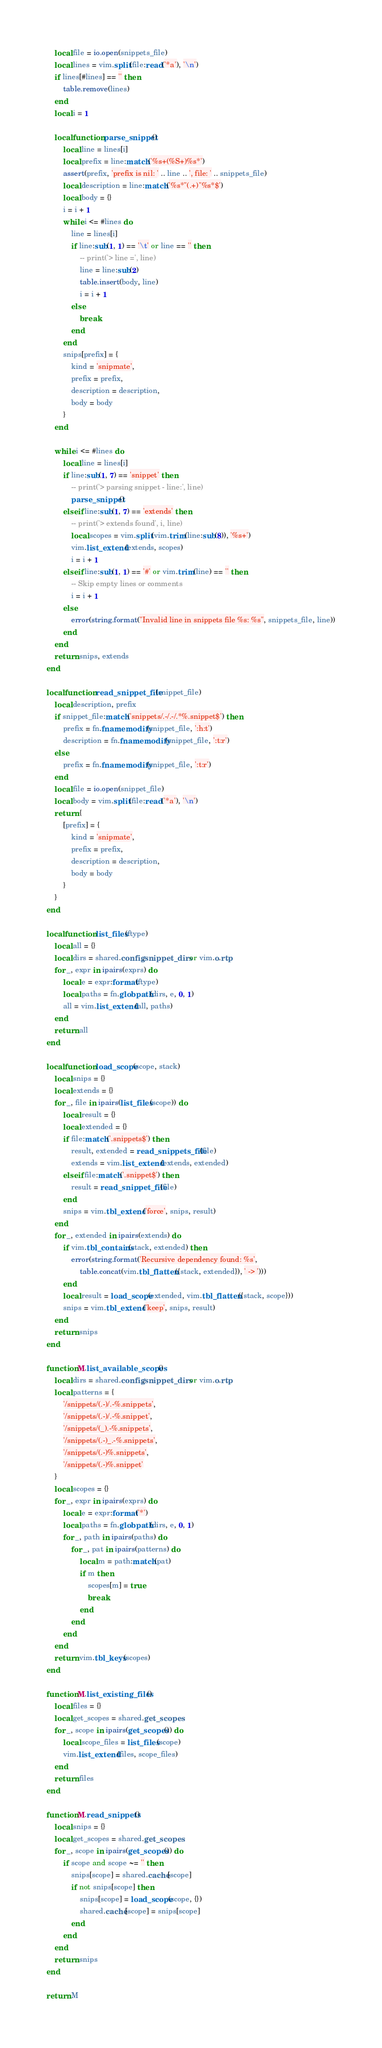<code> <loc_0><loc_0><loc_500><loc_500><_Lua_>    local file = io.open(snippets_file)
    local lines = vim.split(file:read('*a'), '\n')
    if lines[#lines] == '' then
        table.remove(lines)
    end
    local i = 1

    local function parse_snippet()
        local line = lines[i]
        local prefix = line:match('%s+(%S+)%s*')
        assert(prefix, 'prefix is nil: ' .. line .. ', file: ' .. snippets_file)
        local description = line:match('%s*"(.+)"%s*$')
        local body = {}
        i = i + 1
        while i <= #lines do
            line = lines[i]
            if line:sub(1, 1) == '\t' or line == '' then
                -- print('> line =', line)
                line = line:sub(2)
                table.insert(body, line)
                i = i + 1
            else
                break
            end
        end
        snips[prefix] = {
            kind = 'snipmate',
            prefix = prefix,
            description = description,
            body = body
        }
    end

    while i <= #lines do
        local line = lines[i]
        if line:sub(1, 7) == 'snippet' then
            -- print('> parsing snippet - line:', line)
            parse_snippet()
        elseif line:sub(1, 7) == 'extends' then
            -- print('> extends found', i, line)
            local scopes = vim.split(vim.trim(line:sub(8)), '%s+')
            vim.list_extend(extends, scopes)
            i = i + 1
        elseif line:sub(1, 1) == '#' or vim.trim(line) == '' then
            -- Skip empty lines or comments
            i = i + 1
        else
            error(string.format("Invalid line in snippets file %s: %s", snippets_file, line))
        end
    end
    return snips, extends
end

local function read_snippet_file(snippet_file)
    local description, prefix
    if snippet_file:match('snippets/.-/.-/.*%.snippet$') then
        prefix = fn.fnamemodify(snippet_file, ':h:t')
        description = fn.fnamemodify(snippet_file, ':t:r')
    else
        prefix = fn.fnamemodify(snippet_file, ':t:r')
    end
    local file = io.open(snippet_file)
    local body = vim.split(file:read('*a'), '\n')
    return {
        [prefix] = {
            kind = 'snipmate',
            prefix = prefix,
            description = description,
            body = body
        }
    }
end

local function list_files(ftype)
    local all = {}
    local dirs = shared.config.snippet_dirs or vim.o.rtp
    for _, expr in ipairs(exprs) do
        local e = expr:format(ftype)
        local paths = fn.globpath(dirs, e, 0, 1)
        all = vim.list_extend(all, paths)
    end
    return all
end

local function load_scope(scope, stack)
    local snips = {}
    local extends = {}
    for _, file in ipairs(list_files(scope)) do
        local result = {}
        local extended = {}
        if file:match('.snippets$') then
            result, extended = read_snippets_file(file)
            extends = vim.list_extend(extends, extended)
        elseif file:match('.snippet$') then
            result = read_snippet_file(file)
        end
        snips = vim.tbl_extend('force', snips, result)
    end
    for _, extended in ipairs(extends) do
        if vim.tbl_contains(stack, extended) then
            error(string.format('Recursive dependency found: %s',
                table.concat(vim.tbl_flatten({stack, extended}), ' -> ')))
        end
        local result = load_scope(extended, vim.tbl_flatten({stack, scope}))
        snips = vim.tbl_extend('keep', snips, result)
    end
    return snips
end

function M.list_available_scopes()
    local dirs = shared.config.snippet_dirs or vim.o.rtp
    local patterns = {
        '/snippets/(.-)/.-%.snippets',
        '/snippets/(.-)/.-%.snippet',
        '/snippets/(_).-%.snippets',
        '/snippets/(.-)_.-%.snippets',
        '/snippets/(.-)%.snippets',
        '/snippets/(.-)%.snippet'
    }
    local scopes = {}
    for _, expr in ipairs(exprs) do
        local e = expr:format('*')
        local paths = fn.globpath(dirs, e, 0, 1)
        for _, path in ipairs(paths) do
            for _, pat in ipairs(patterns) do
                local m = path:match(pat)
                if m then
                    scopes[m] = true
                    break
                end
            end
        end
    end
    return vim.tbl_keys(scopes)
end

function M.list_existing_files()
    local files = {}
    local get_scopes = shared.get_scopes
    for _, scope in ipairs(get_scopes()) do
        local scope_files = list_files(scope)
        vim.list_extend(files, scope_files)
    end
    return files
end

function M.read_snippets()
    local snips = {}
    local get_scopes = shared.get_scopes
    for _, scope in ipairs(get_scopes()) do
        if scope and scope ~= '' then
            snips[scope] = shared.cache[scope]
            if not snips[scope] then
                snips[scope] = load_scope(scope, {})
                shared.cache[scope] = snips[scope]
            end
        end
    end
    return snips
end

return M
</code> 